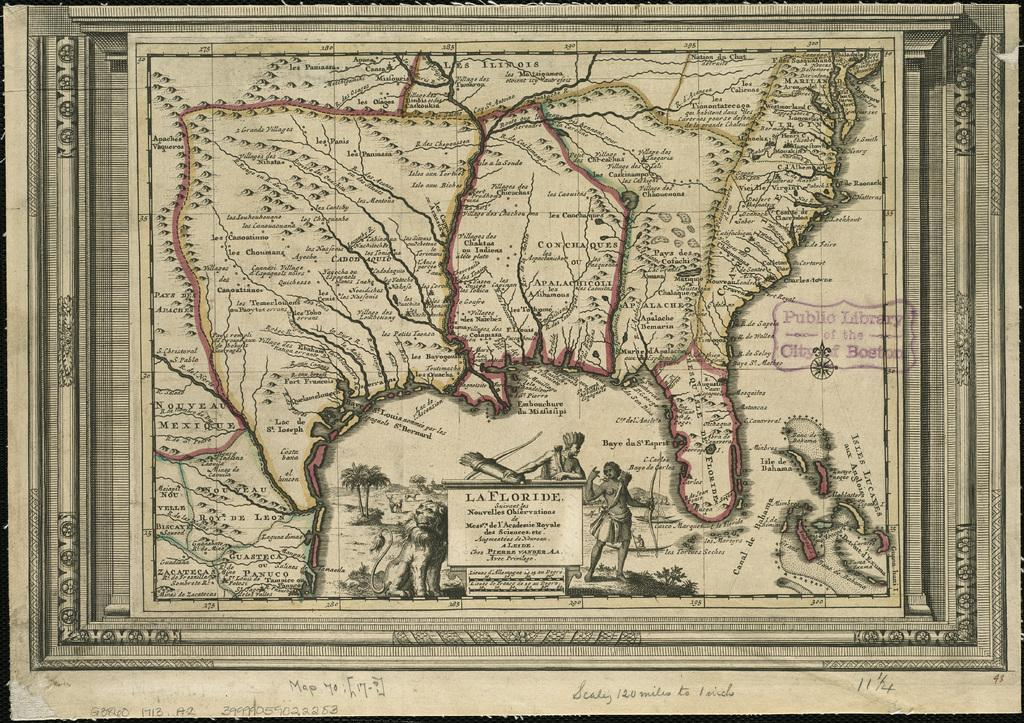What type of map is depicted in the image? The image contains an ancient map. What is the subject of the ancient map? The map is of a city. Can you see a beggar on the ancient map in the image? There is no beggar present on the ancient map in the image, as the map is a depiction of a city and not a photograph or illustration of a specific moment in time. 